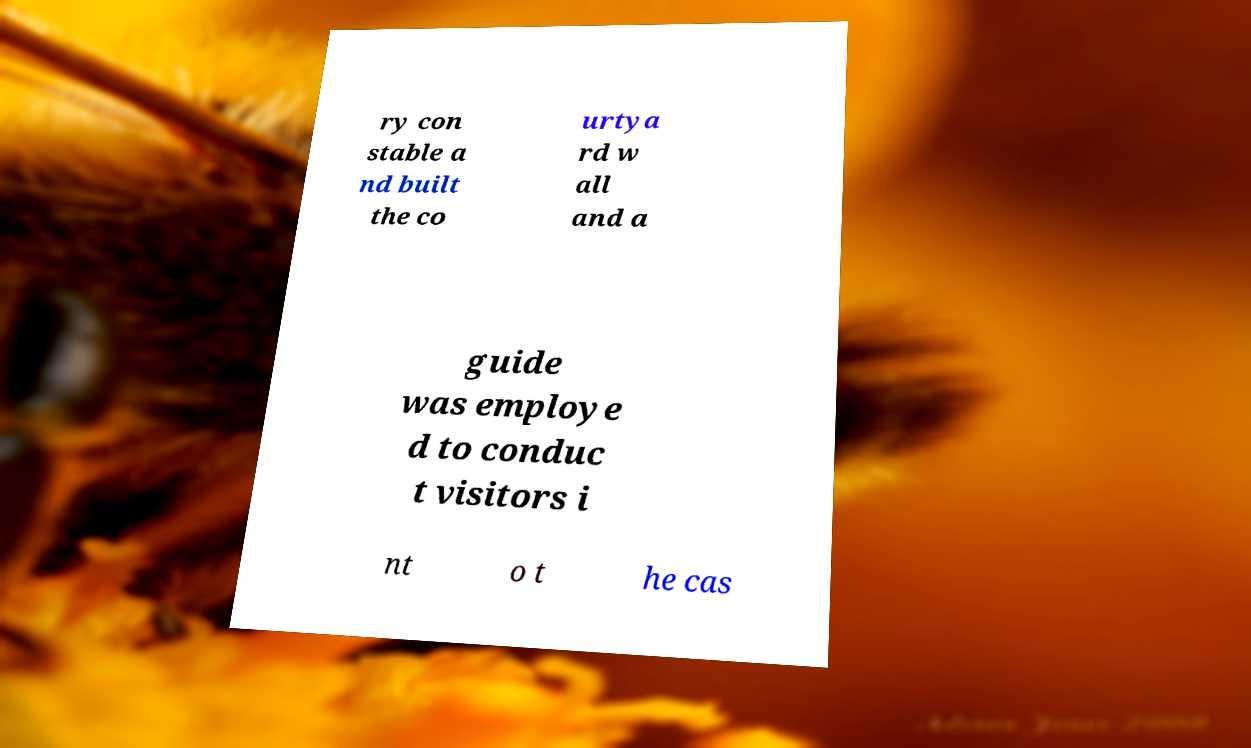Please identify and transcribe the text found in this image. ry con stable a nd built the co urtya rd w all and a guide was employe d to conduc t visitors i nt o t he cas 